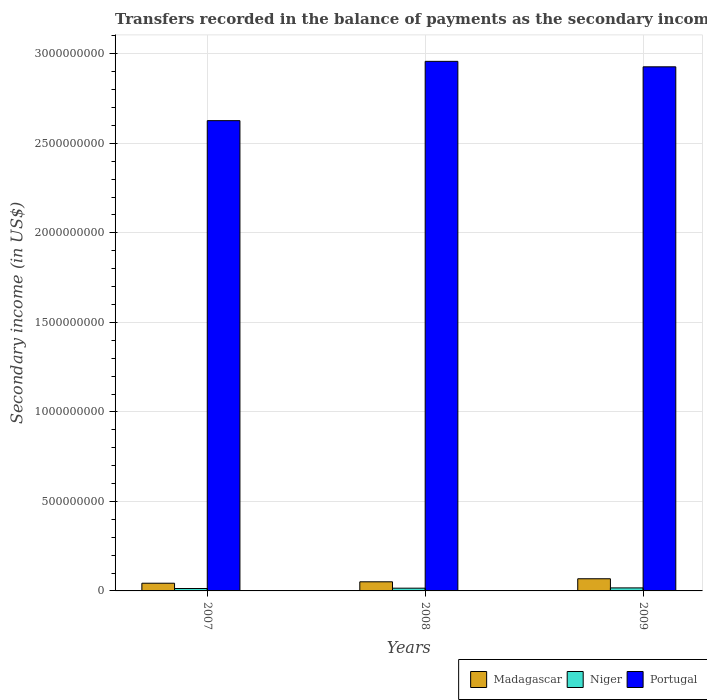How many different coloured bars are there?
Make the answer very short. 3. How many groups of bars are there?
Offer a terse response. 3. How many bars are there on the 3rd tick from the right?
Make the answer very short. 3. In how many cases, is the number of bars for a given year not equal to the number of legend labels?
Provide a succinct answer. 0. What is the secondary income of in Madagascar in 2009?
Your answer should be very brief. 6.79e+07. Across all years, what is the maximum secondary income of in Portugal?
Give a very brief answer. 2.96e+09. Across all years, what is the minimum secondary income of in Niger?
Your answer should be very brief. 1.35e+07. In which year was the secondary income of in Niger maximum?
Ensure brevity in your answer.  2009. What is the total secondary income of in Niger in the graph?
Provide a succinct answer. 4.56e+07. What is the difference between the secondary income of in Portugal in 2008 and that in 2009?
Your response must be concise. 3.05e+07. What is the difference between the secondary income of in Portugal in 2008 and the secondary income of in Niger in 2009?
Make the answer very short. 2.94e+09. What is the average secondary income of in Madagascar per year?
Offer a very short reply. 5.40e+07. In the year 2009, what is the difference between the secondary income of in Niger and secondary income of in Madagascar?
Your answer should be very brief. -5.11e+07. What is the ratio of the secondary income of in Niger in 2007 to that in 2009?
Give a very brief answer. 0.8. Is the difference between the secondary income of in Niger in 2007 and 2009 greater than the difference between the secondary income of in Madagascar in 2007 and 2009?
Keep it short and to the point. Yes. What is the difference between the highest and the second highest secondary income of in Portugal?
Give a very brief answer. 3.05e+07. What is the difference between the highest and the lowest secondary income of in Madagascar?
Provide a short and direct response. 2.50e+07. Is the sum of the secondary income of in Madagascar in 2007 and 2008 greater than the maximum secondary income of in Portugal across all years?
Provide a succinct answer. No. What does the 3rd bar from the left in 2009 represents?
Your answer should be compact. Portugal. What does the 1st bar from the right in 2009 represents?
Offer a terse response. Portugal. Is it the case that in every year, the sum of the secondary income of in Niger and secondary income of in Madagascar is greater than the secondary income of in Portugal?
Ensure brevity in your answer.  No. How many bars are there?
Make the answer very short. 9. Does the graph contain any zero values?
Ensure brevity in your answer.  No. Does the graph contain grids?
Your answer should be compact. Yes. How are the legend labels stacked?
Your response must be concise. Horizontal. What is the title of the graph?
Your answer should be very brief. Transfers recorded in the balance of payments as the secondary income of a country. Does "Chile" appear as one of the legend labels in the graph?
Your answer should be compact. No. What is the label or title of the X-axis?
Offer a terse response. Years. What is the label or title of the Y-axis?
Give a very brief answer. Secondary income (in US$). What is the Secondary income (in US$) of Madagascar in 2007?
Your response must be concise. 4.30e+07. What is the Secondary income (in US$) of Niger in 2007?
Offer a terse response. 1.35e+07. What is the Secondary income (in US$) in Portugal in 2007?
Provide a short and direct response. 2.63e+09. What is the Secondary income (in US$) of Madagascar in 2008?
Offer a very short reply. 5.10e+07. What is the Secondary income (in US$) of Niger in 2008?
Provide a succinct answer. 1.53e+07. What is the Secondary income (in US$) in Portugal in 2008?
Keep it short and to the point. 2.96e+09. What is the Secondary income (in US$) in Madagascar in 2009?
Your answer should be compact. 6.79e+07. What is the Secondary income (in US$) in Niger in 2009?
Your answer should be very brief. 1.69e+07. What is the Secondary income (in US$) in Portugal in 2009?
Your answer should be compact. 2.93e+09. Across all years, what is the maximum Secondary income (in US$) of Madagascar?
Give a very brief answer. 6.79e+07. Across all years, what is the maximum Secondary income (in US$) in Niger?
Your response must be concise. 1.69e+07. Across all years, what is the maximum Secondary income (in US$) in Portugal?
Your answer should be very brief. 2.96e+09. Across all years, what is the minimum Secondary income (in US$) in Madagascar?
Give a very brief answer. 4.30e+07. Across all years, what is the minimum Secondary income (in US$) in Niger?
Your answer should be very brief. 1.35e+07. Across all years, what is the minimum Secondary income (in US$) in Portugal?
Keep it short and to the point. 2.63e+09. What is the total Secondary income (in US$) of Madagascar in the graph?
Provide a short and direct response. 1.62e+08. What is the total Secondary income (in US$) of Niger in the graph?
Make the answer very short. 4.56e+07. What is the total Secondary income (in US$) in Portugal in the graph?
Give a very brief answer. 8.51e+09. What is the difference between the Secondary income (in US$) in Madagascar in 2007 and that in 2008?
Provide a succinct answer. -7.99e+06. What is the difference between the Secondary income (in US$) in Niger in 2007 and that in 2008?
Ensure brevity in your answer.  -1.83e+06. What is the difference between the Secondary income (in US$) in Portugal in 2007 and that in 2008?
Give a very brief answer. -3.31e+08. What is the difference between the Secondary income (in US$) in Madagascar in 2007 and that in 2009?
Your answer should be very brief. -2.50e+07. What is the difference between the Secondary income (in US$) of Niger in 2007 and that in 2009?
Your answer should be very brief. -3.37e+06. What is the difference between the Secondary income (in US$) in Portugal in 2007 and that in 2009?
Make the answer very short. -3.01e+08. What is the difference between the Secondary income (in US$) in Madagascar in 2008 and that in 2009?
Offer a terse response. -1.70e+07. What is the difference between the Secondary income (in US$) in Niger in 2008 and that in 2009?
Provide a short and direct response. -1.55e+06. What is the difference between the Secondary income (in US$) of Portugal in 2008 and that in 2009?
Provide a short and direct response. 3.05e+07. What is the difference between the Secondary income (in US$) of Madagascar in 2007 and the Secondary income (in US$) of Niger in 2008?
Provide a succinct answer. 2.77e+07. What is the difference between the Secondary income (in US$) in Madagascar in 2007 and the Secondary income (in US$) in Portugal in 2008?
Offer a terse response. -2.92e+09. What is the difference between the Secondary income (in US$) in Niger in 2007 and the Secondary income (in US$) in Portugal in 2008?
Offer a very short reply. -2.94e+09. What is the difference between the Secondary income (in US$) in Madagascar in 2007 and the Secondary income (in US$) in Niger in 2009?
Your answer should be very brief. 2.61e+07. What is the difference between the Secondary income (in US$) of Madagascar in 2007 and the Secondary income (in US$) of Portugal in 2009?
Your response must be concise. -2.88e+09. What is the difference between the Secondary income (in US$) of Niger in 2007 and the Secondary income (in US$) of Portugal in 2009?
Ensure brevity in your answer.  -2.91e+09. What is the difference between the Secondary income (in US$) of Madagascar in 2008 and the Secondary income (in US$) of Niger in 2009?
Your response must be concise. 3.41e+07. What is the difference between the Secondary income (in US$) in Madagascar in 2008 and the Secondary income (in US$) in Portugal in 2009?
Your answer should be very brief. -2.88e+09. What is the difference between the Secondary income (in US$) of Niger in 2008 and the Secondary income (in US$) of Portugal in 2009?
Make the answer very short. -2.91e+09. What is the average Secondary income (in US$) of Madagascar per year?
Give a very brief answer. 5.40e+07. What is the average Secondary income (in US$) in Niger per year?
Provide a short and direct response. 1.52e+07. What is the average Secondary income (in US$) in Portugal per year?
Provide a short and direct response. 2.84e+09. In the year 2007, what is the difference between the Secondary income (in US$) in Madagascar and Secondary income (in US$) in Niger?
Provide a short and direct response. 2.95e+07. In the year 2007, what is the difference between the Secondary income (in US$) of Madagascar and Secondary income (in US$) of Portugal?
Ensure brevity in your answer.  -2.58e+09. In the year 2007, what is the difference between the Secondary income (in US$) in Niger and Secondary income (in US$) in Portugal?
Your answer should be very brief. -2.61e+09. In the year 2008, what is the difference between the Secondary income (in US$) of Madagascar and Secondary income (in US$) of Niger?
Make the answer very short. 3.57e+07. In the year 2008, what is the difference between the Secondary income (in US$) in Madagascar and Secondary income (in US$) in Portugal?
Offer a terse response. -2.91e+09. In the year 2008, what is the difference between the Secondary income (in US$) in Niger and Secondary income (in US$) in Portugal?
Provide a short and direct response. -2.94e+09. In the year 2009, what is the difference between the Secondary income (in US$) in Madagascar and Secondary income (in US$) in Niger?
Keep it short and to the point. 5.11e+07. In the year 2009, what is the difference between the Secondary income (in US$) in Madagascar and Secondary income (in US$) in Portugal?
Offer a terse response. -2.86e+09. In the year 2009, what is the difference between the Secondary income (in US$) of Niger and Secondary income (in US$) of Portugal?
Your response must be concise. -2.91e+09. What is the ratio of the Secondary income (in US$) in Madagascar in 2007 to that in 2008?
Your answer should be very brief. 0.84. What is the ratio of the Secondary income (in US$) of Niger in 2007 to that in 2008?
Your answer should be very brief. 0.88. What is the ratio of the Secondary income (in US$) in Portugal in 2007 to that in 2008?
Make the answer very short. 0.89. What is the ratio of the Secondary income (in US$) in Madagascar in 2007 to that in 2009?
Your answer should be compact. 0.63. What is the ratio of the Secondary income (in US$) in Niger in 2007 to that in 2009?
Keep it short and to the point. 0.8. What is the ratio of the Secondary income (in US$) in Portugal in 2007 to that in 2009?
Ensure brevity in your answer.  0.9. What is the ratio of the Secondary income (in US$) of Madagascar in 2008 to that in 2009?
Your answer should be compact. 0.75. What is the ratio of the Secondary income (in US$) of Niger in 2008 to that in 2009?
Your answer should be very brief. 0.91. What is the ratio of the Secondary income (in US$) in Portugal in 2008 to that in 2009?
Your answer should be very brief. 1.01. What is the difference between the highest and the second highest Secondary income (in US$) in Madagascar?
Provide a succinct answer. 1.70e+07. What is the difference between the highest and the second highest Secondary income (in US$) in Niger?
Offer a very short reply. 1.55e+06. What is the difference between the highest and the second highest Secondary income (in US$) of Portugal?
Provide a short and direct response. 3.05e+07. What is the difference between the highest and the lowest Secondary income (in US$) of Madagascar?
Give a very brief answer. 2.50e+07. What is the difference between the highest and the lowest Secondary income (in US$) of Niger?
Your answer should be compact. 3.37e+06. What is the difference between the highest and the lowest Secondary income (in US$) in Portugal?
Make the answer very short. 3.31e+08. 